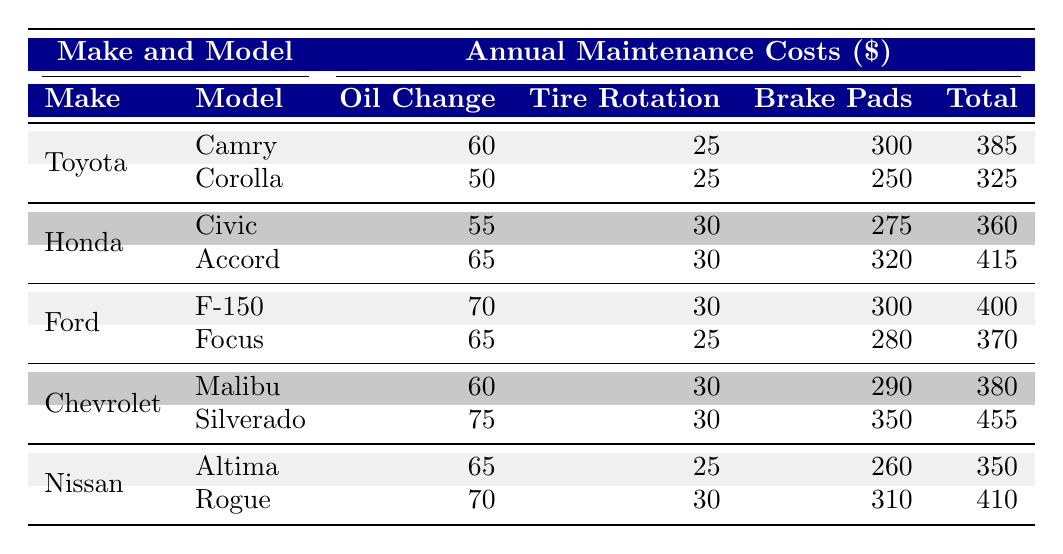What is the total maintenance cost for a Honda Accord? The table shows that the annual maintenance cost for a Honda Accord is listed under the "Total" column as 415.
Answer: 415 Which car make has the highest total maintenance cost? Upon reviewing the "Total" column, Chevrolet Silverado shows the highest maintenance cost at 455.
Answer: Chevrolet Silverado What is the difference between the total maintenance costs of the Ford F-150 and the Ford Focus? The total for the Ford F-150 is 400, and the total for the Ford Focus is 370. The difference is 400 - 370 = 30.
Answer: 30 Is the cost of brake pads replacement higher for the Toyota Camry than the Honda Civic? The brake pads replacement cost for Toyota Camry is 300, while for Honda Civic it is 275. Since 300 is greater than 275, the statement is true.
Answer: Yes What is the average cost of oil changes for all car makes? The oil change costs are: Toyota Camry (60), Corolla (50), Honda Civic (55), Accord (65), Ford F-150 (70), Focus (65), Chevrolet Malibu (60), Silverado (75), Nissan Altima (65), Rogue (70). Summing these gives 60 + 50 + 55 + 65 + 70 + 65 + 60 + 75 + 65 + 70 = 725. There are 10 data points, so the average is 725/10 = 72.5.
Answer: 72.5 Which model has the lowest maintenance cost overall? The total for the Toyota Corolla is 325, which is the lowest among all the models when comparing the "Total" column values across the table.
Answer: Toyota Corolla 